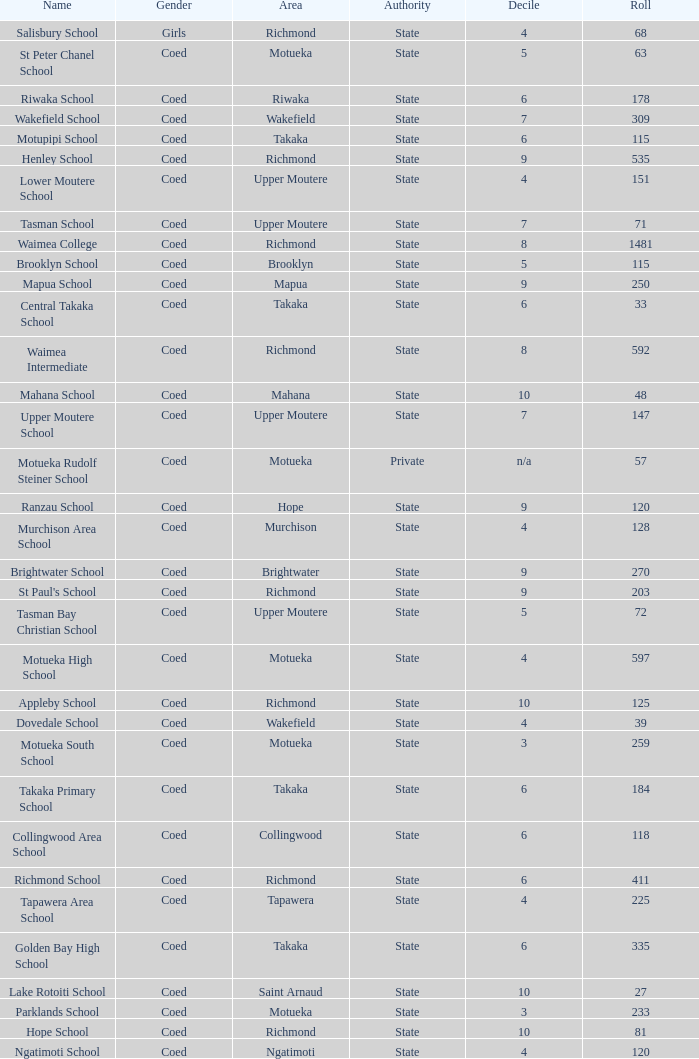What area is Central Takaka School in? Takaka. 